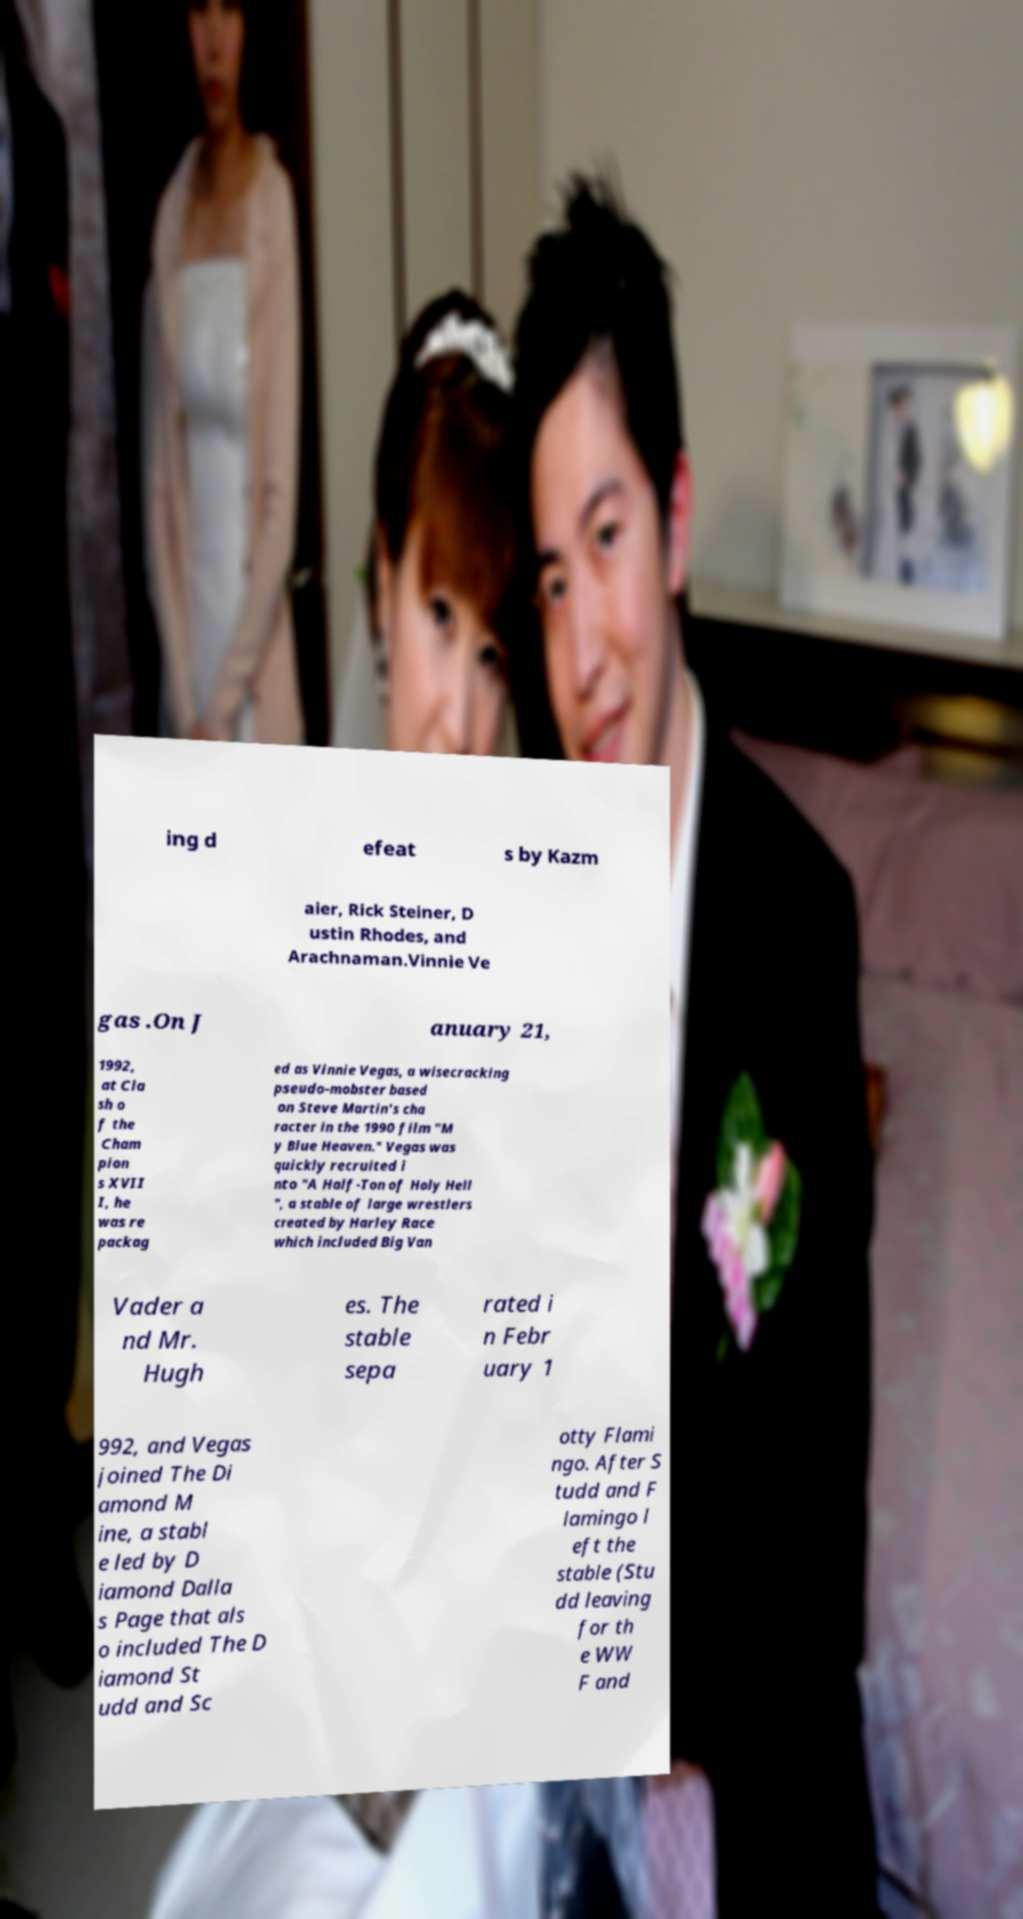I need the written content from this picture converted into text. Can you do that? ing d efeat s by Kazm aier, Rick Steiner, D ustin Rhodes, and Arachnaman.Vinnie Ve gas .On J anuary 21, 1992, at Cla sh o f the Cham pion s XVII I, he was re packag ed as Vinnie Vegas, a wisecracking pseudo-mobster based on Steve Martin's cha racter in the 1990 film "M y Blue Heaven." Vegas was quickly recruited i nto "A Half-Ton of Holy Hell ", a stable of large wrestlers created by Harley Race which included Big Van Vader a nd Mr. Hugh es. The stable sepa rated i n Febr uary 1 992, and Vegas joined The Di amond M ine, a stabl e led by D iamond Dalla s Page that als o included The D iamond St udd and Sc otty Flami ngo. After S tudd and F lamingo l eft the stable (Stu dd leaving for th e WW F and 